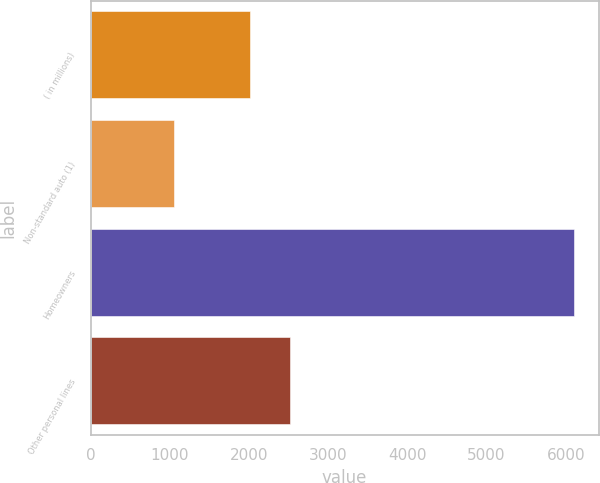Convert chart. <chart><loc_0><loc_0><loc_500><loc_500><bar_chart><fcel>( in millions)<fcel>Non-standard auto (1)<fcel>Homeowners<fcel>Other personal lines<nl><fcel>2008<fcel>1058<fcel>6110<fcel>2513.2<nl></chart> 